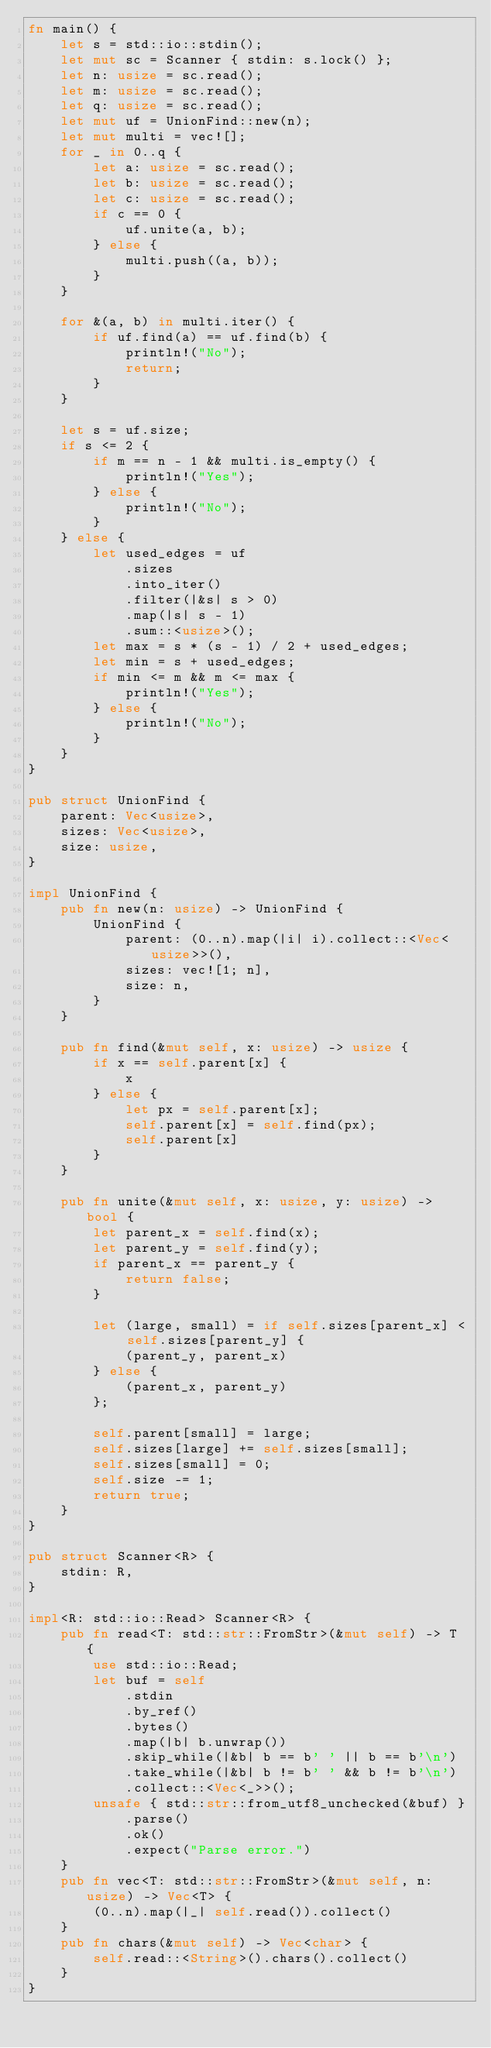<code> <loc_0><loc_0><loc_500><loc_500><_Rust_>fn main() {
    let s = std::io::stdin();
    let mut sc = Scanner { stdin: s.lock() };
    let n: usize = sc.read();
    let m: usize = sc.read();
    let q: usize = sc.read();
    let mut uf = UnionFind::new(n);
    let mut multi = vec![];
    for _ in 0..q {
        let a: usize = sc.read();
        let b: usize = sc.read();
        let c: usize = sc.read();
        if c == 0 {
            uf.unite(a, b);
        } else {
            multi.push((a, b));
        }
    }

    for &(a, b) in multi.iter() {
        if uf.find(a) == uf.find(b) {
            println!("No");
            return;
        }
    }

    let s = uf.size;
    if s <= 2 {
        if m == n - 1 && multi.is_empty() {
            println!("Yes");
        } else {
            println!("No");
        }
    } else {
        let used_edges = uf
            .sizes
            .into_iter()
            .filter(|&s| s > 0)
            .map(|s| s - 1)
            .sum::<usize>();
        let max = s * (s - 1) / 2 + used_edges;
        let min = s + used_edges;
        if min <= m && m <= max {
            println!("Yes");
        } else {
            println!("No");
        }
    }
}

pub struct UnionFind {
    parent: Vec<usize>,
    sizes: Vec<usize>,
    size: usize,
}

impl UnionFind {
    pub fn new(n: usize) -> UnionFind {
        UnionFind {
            parent: (0..n).map(|i| i).collect::<Vec<usize>>(),
            sizes: vec![1; n],
            size: n,
        }
    }

    pub fn find(&mut self, x: usize) -> usize {
        if x == self.parent[x] {
            x
        } else {
            let px = self.parent[x];
            self.parent[x] = self.find(px);
            self.parent[x]
        }
    }

    pub fn unite(&mut self, x: usize, y: usize) -> bool {
        let parent_x = self.find(x);
        let parent_y = self.find(y);
        if parent_x == parent_y {
            return false;
        }

        let (large, small) = if self.sizes[parent_x] < self.sizes[parent_y] {
            (parent_y, parent_x)
        } else {
            (parent_x, parent_y)
        };

        self.parent[small] = large;
        self.sizes[large] += self.sizes[small];
        self.sizes[small] = 0;
        self.size -= 1;
        return true;
    }
}

pub struct Scanner<R> {
    stdin: R,
}

impl<R: std::io::Read> Scanner<R> {
    pub fn read<T: std::str::FromStr>(&mut self) -> T {
        use std::io::Read;
        let buf = self
            .stdin
            .by_ref()
            .bytes()
            .map(|b| b.unwrap())
            .skip_while(|&b| b == b' ' || b == b'\n')
            .take_while(|&b| b != b' ' && b != b'\n')
            .collect::<Vec<_>>();
        unsafe { std::str::from_utf8_unchecked(&buf) }
            .parse()
            .ok()
            .expect("Parse error.")
    }
    pub fn vec<T: std::str::FromStr>(&mut self, n: usize) -> Vec<T> {
        (0..n).map(|_| self.read()).collect()
    }
    pub fn chars(&mut self) -> Vec<char> {
        self.read::<String>().chars().collect()
    }
}
</code> 